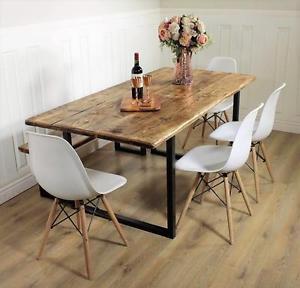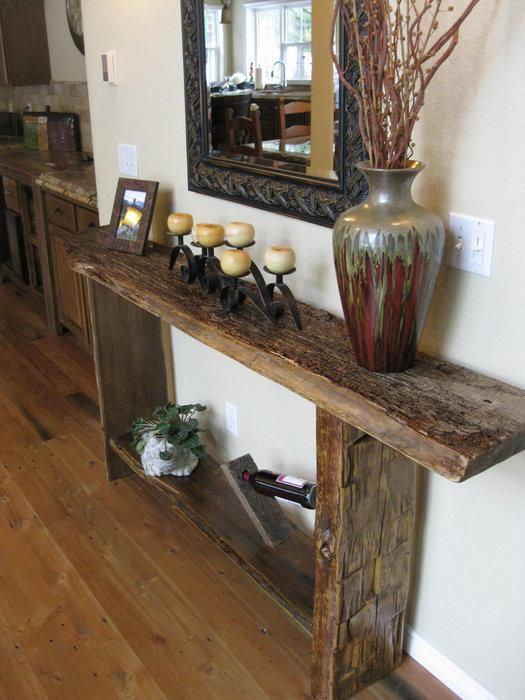The first image is the image on the left, the second image is the image on the right. Evaluate the accuracy of this statement regarding the images: "There is a vase with flowers in the image on the left.". Is it true? Answer yes or no. Yes. 